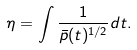<formula> <loc_0><loc_0><loc_500><loc_500>\eta = \int \frac { 1 } { \bar { p } ( t ) ^ { 1 / 2 } } d t .</formula> 